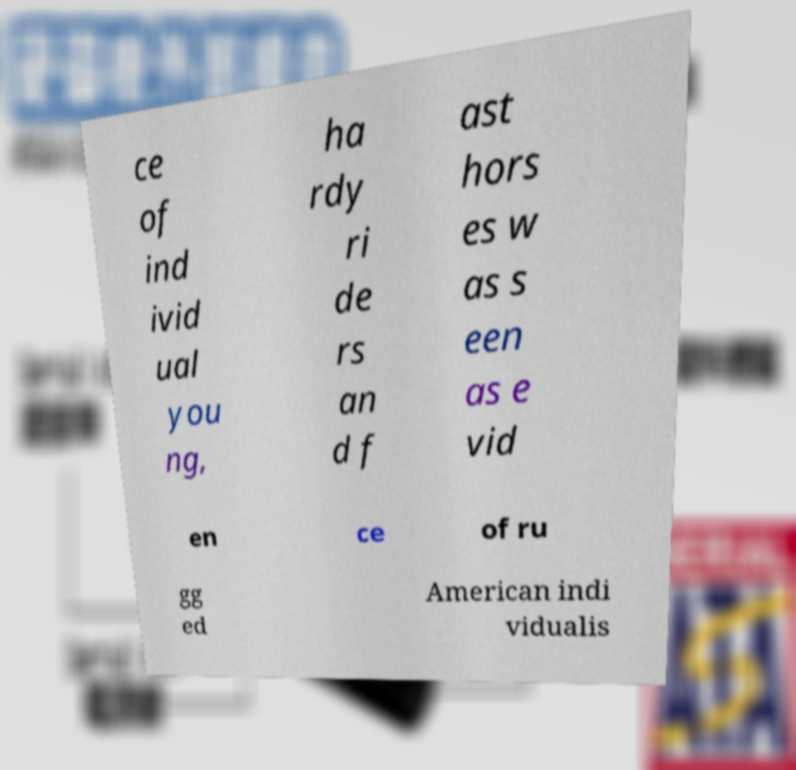Can you read and provide the text displayed in the image?This photo seems to have some interesting text. Can you extract and type it out for me? ce of ind ivid ual you ng, ha rdy ri de rs an d f ast hors es w as s een as e vid en ce of ru gg ed American indi vidualis 